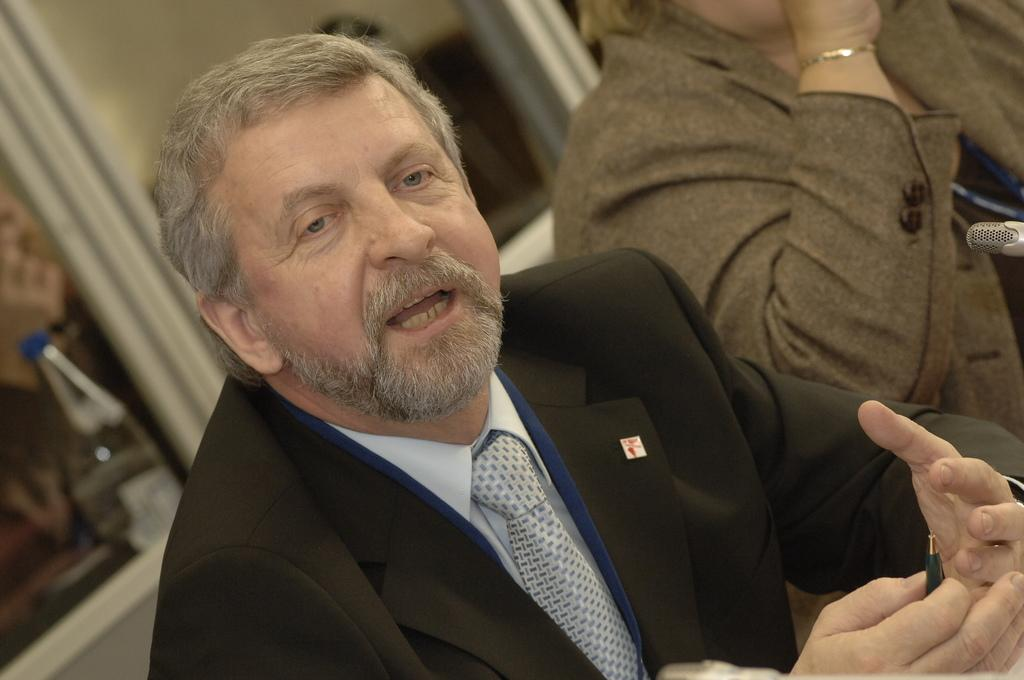What is the man in the image holding in his hand? The man is holding a pen in his hand. What can be seen in the background of the image? There is a bottle, doors, at least two persons, a wall, and a microphone on the right side of the image. Can you describe the microphone in the image? The microphone is on the right side of the image. What route does the group take in the image? There is no group present in the image, so it is not possible to determine a route. 